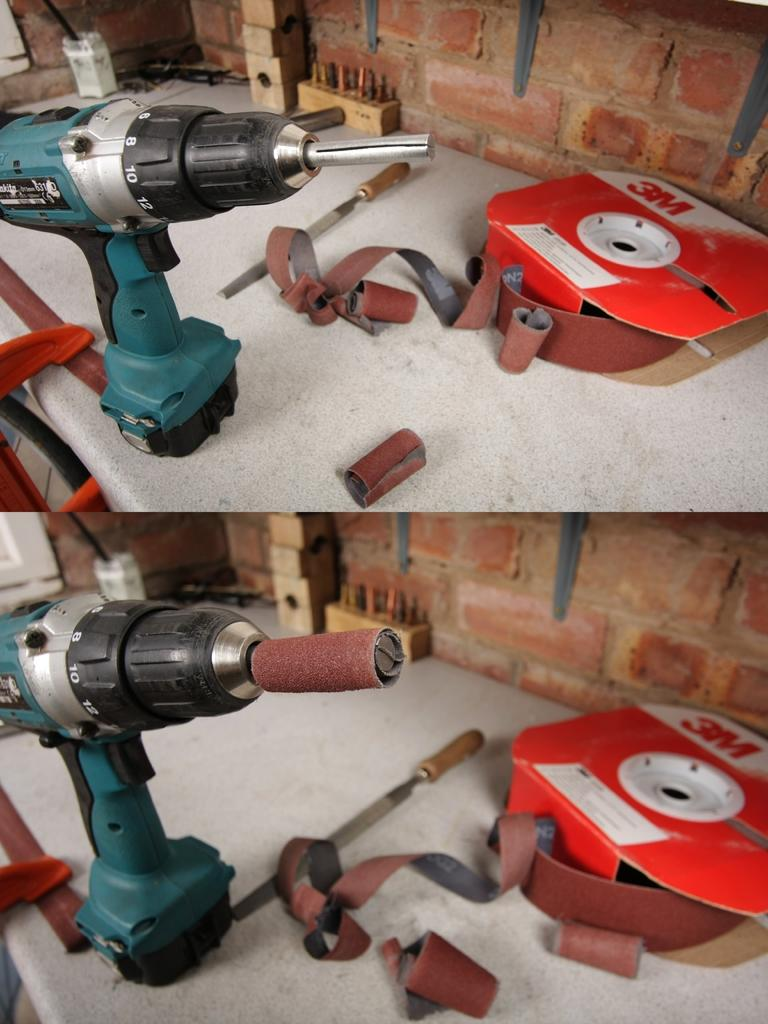What is the main object in the image? There is a hole drilling machine in the image. What else can be seen in the image besides the hole drilling machine? There are other tools present in the image. Where are the tools located? The tools are on a table. What type of vessel is sailing through the air in the image? There is no vessel sailing through the air in the image; it only features a hole drilling machine and other tools on a table. 